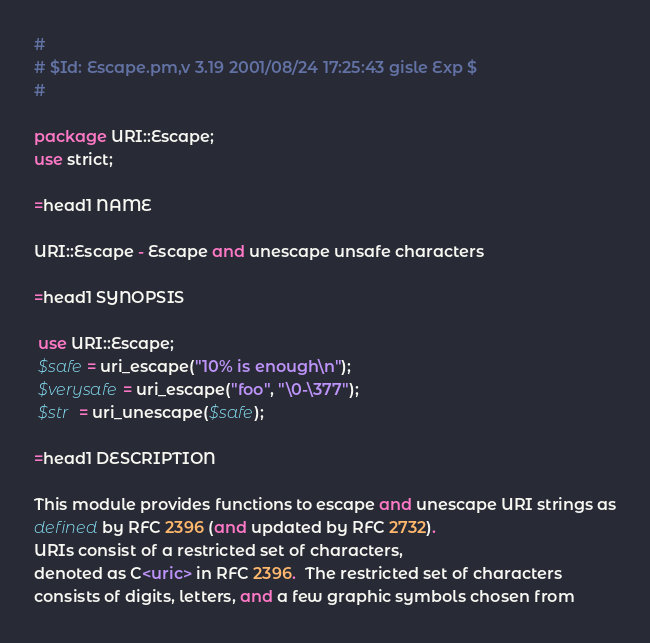<code> <loc_0><loc_0><loc_500><loc_500><_Perl_>#
# $Id: Escape.pm,v 3.19 2001/08/24 17:25:43 gisle Exp $
#

package URI::Escape;
use strict;

=head1 NAME

URI::Escape - Escape and unescape unsafe characters

=head1 SYNOPSIS

 use URI::Escape;
 $safe = uri_escape("10% is enough\n");
 $verysafe = uri_escape("foo", "\0-\377");
 $str  = uri_unescape($safe);

=head1 DESCRIPTION

This module provides functions to escape and unescape URI strings as
defined by RFC 2396 (and updated by RFC 2732).
URIs consist of a restricted set of characters,
denoted as C<uric> in RFC 2396.  The restricted set of characters
consists of digits, letters, and a few graphic symbols chosen from</code> 